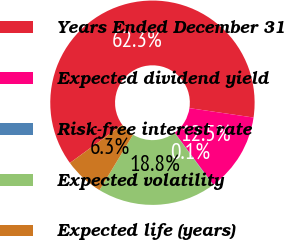Convert chart. <chart><loc_0><loc_0><loc_500><loc_500><pie_chart><fcel>Years Ended December 31<fcel>Expected dividend yield<fcel>Risk-free interest rate<fcel>Expected volatility<fcel>Expected life (years)<nl><fcel>62.35%<fcel>12.53%<fcel>0.07%<fcel>18.75%<fcel>6.3%<nl></chart> 